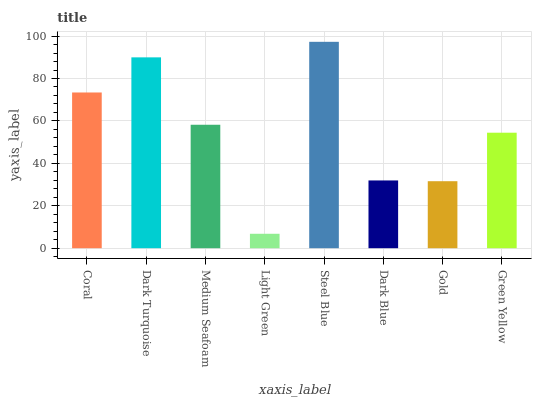Is Light Green the minimum?
Answer yes or no. Yes. Is Steel Blue the maximum?
Answer yes or no. Yes. Is Dark Turquoise the minimum?
Answer yes or no. No. Is Dark Turquoise the maximum?
Answer yes or no. No. Is Dark Turquoise greater than Coral?
Answer yes or no. Yes. Is Coral less than Dark Turquoise?
Answer yes or no. Yes. Is Coral greater than Dark Turquoise?
Answer yes or no. No. Is Dark Turquoise less than Coral?
Answer yes or no. No. Is Medium Seafoam the high median?
Answer yes or no. Yes. Is Green Yellow the low median?
Answer yes or no. Yes. Is Green Yellow the high median?
Answer yes or no. No. Is Dark Blue the low median?
Answer yes or no. No. 